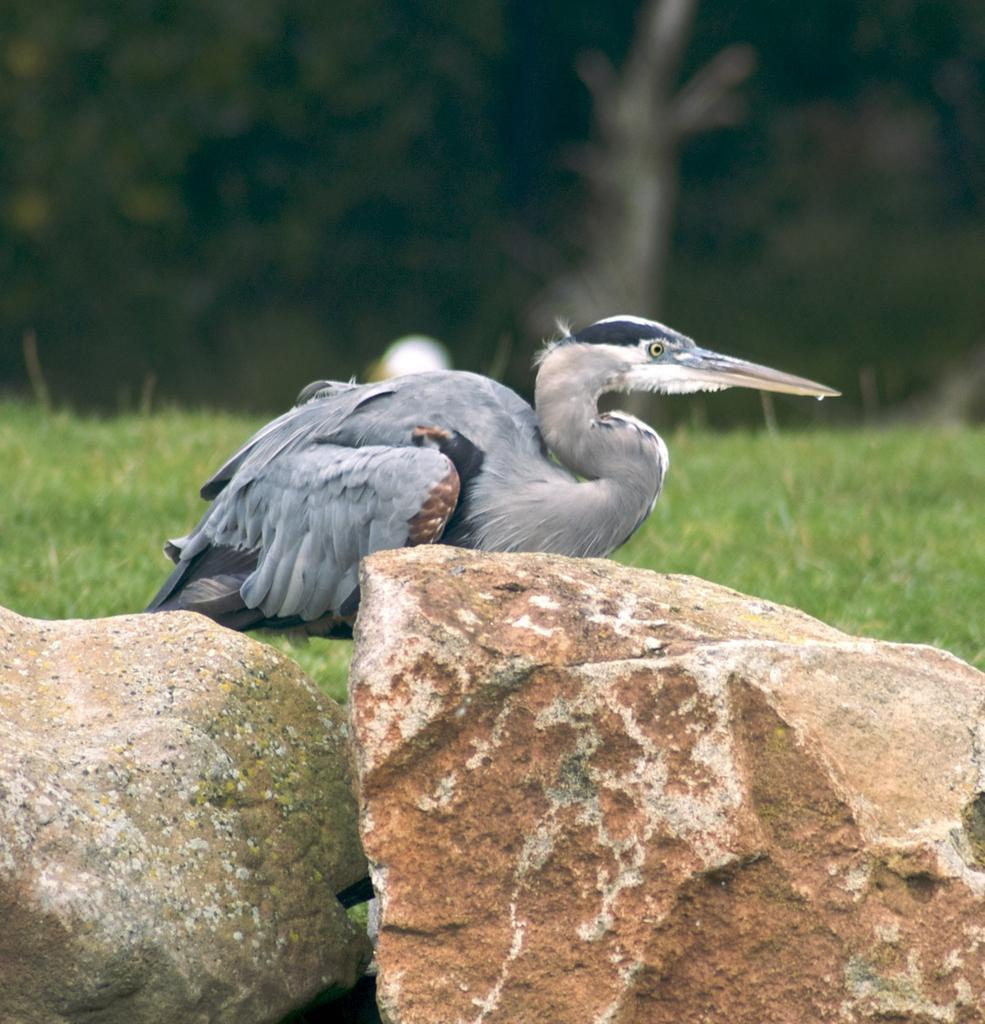What type of animal can be seen in the image? There is a bird in the image. What other objects are present in the image? There are stones in the image. What can be seen in the background of the image? The background of the image includes grass. How is the grass in the background depicted? The grass in the background appears blurry. What type of flame can be seen on the bird's wing in the image? There is no flame present on the bird's wing in the image. What sense does the bird use to detect the stones in the image? The bird's sense of sight is used to detect the stones in the image, as there is no mention of any other senses being involved. 